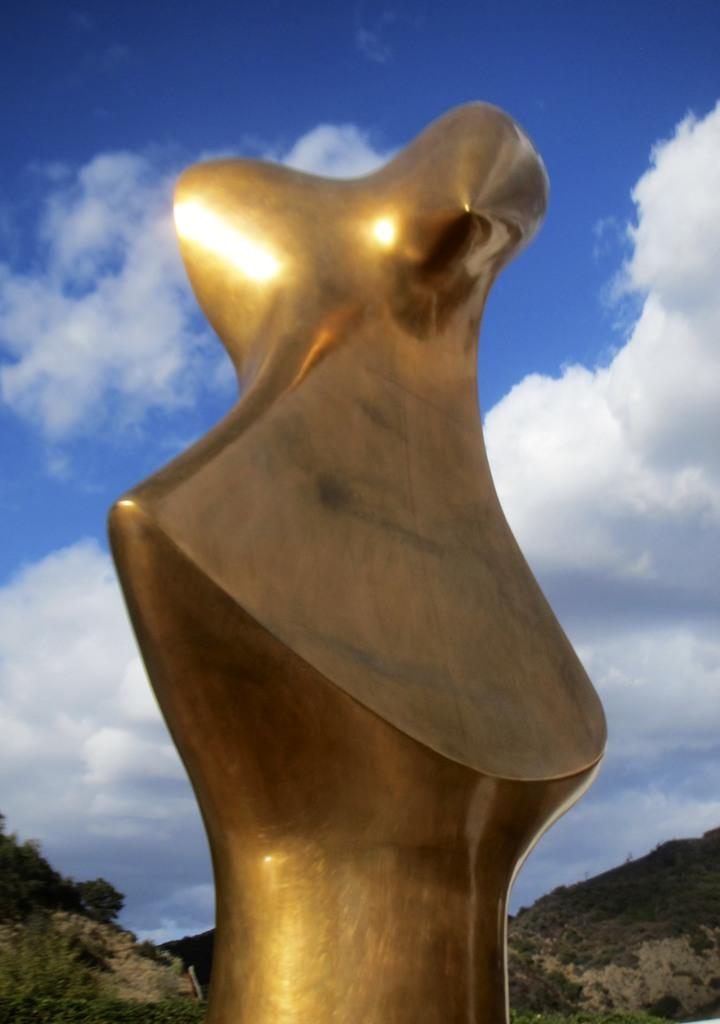What type of building is in the image? There is a golden building in the image. What can be seen in the background of the image? Hills are visible in the background of the image. How are the hills described in the image? The hills are covered with plants. Are there any trees on the hills in the image? Yes, trees are present on the hills in the image. What type of behavior can be observed in the cows in the image? There are no cows present in the image; it features a golden building, hills, plants, and trees. 